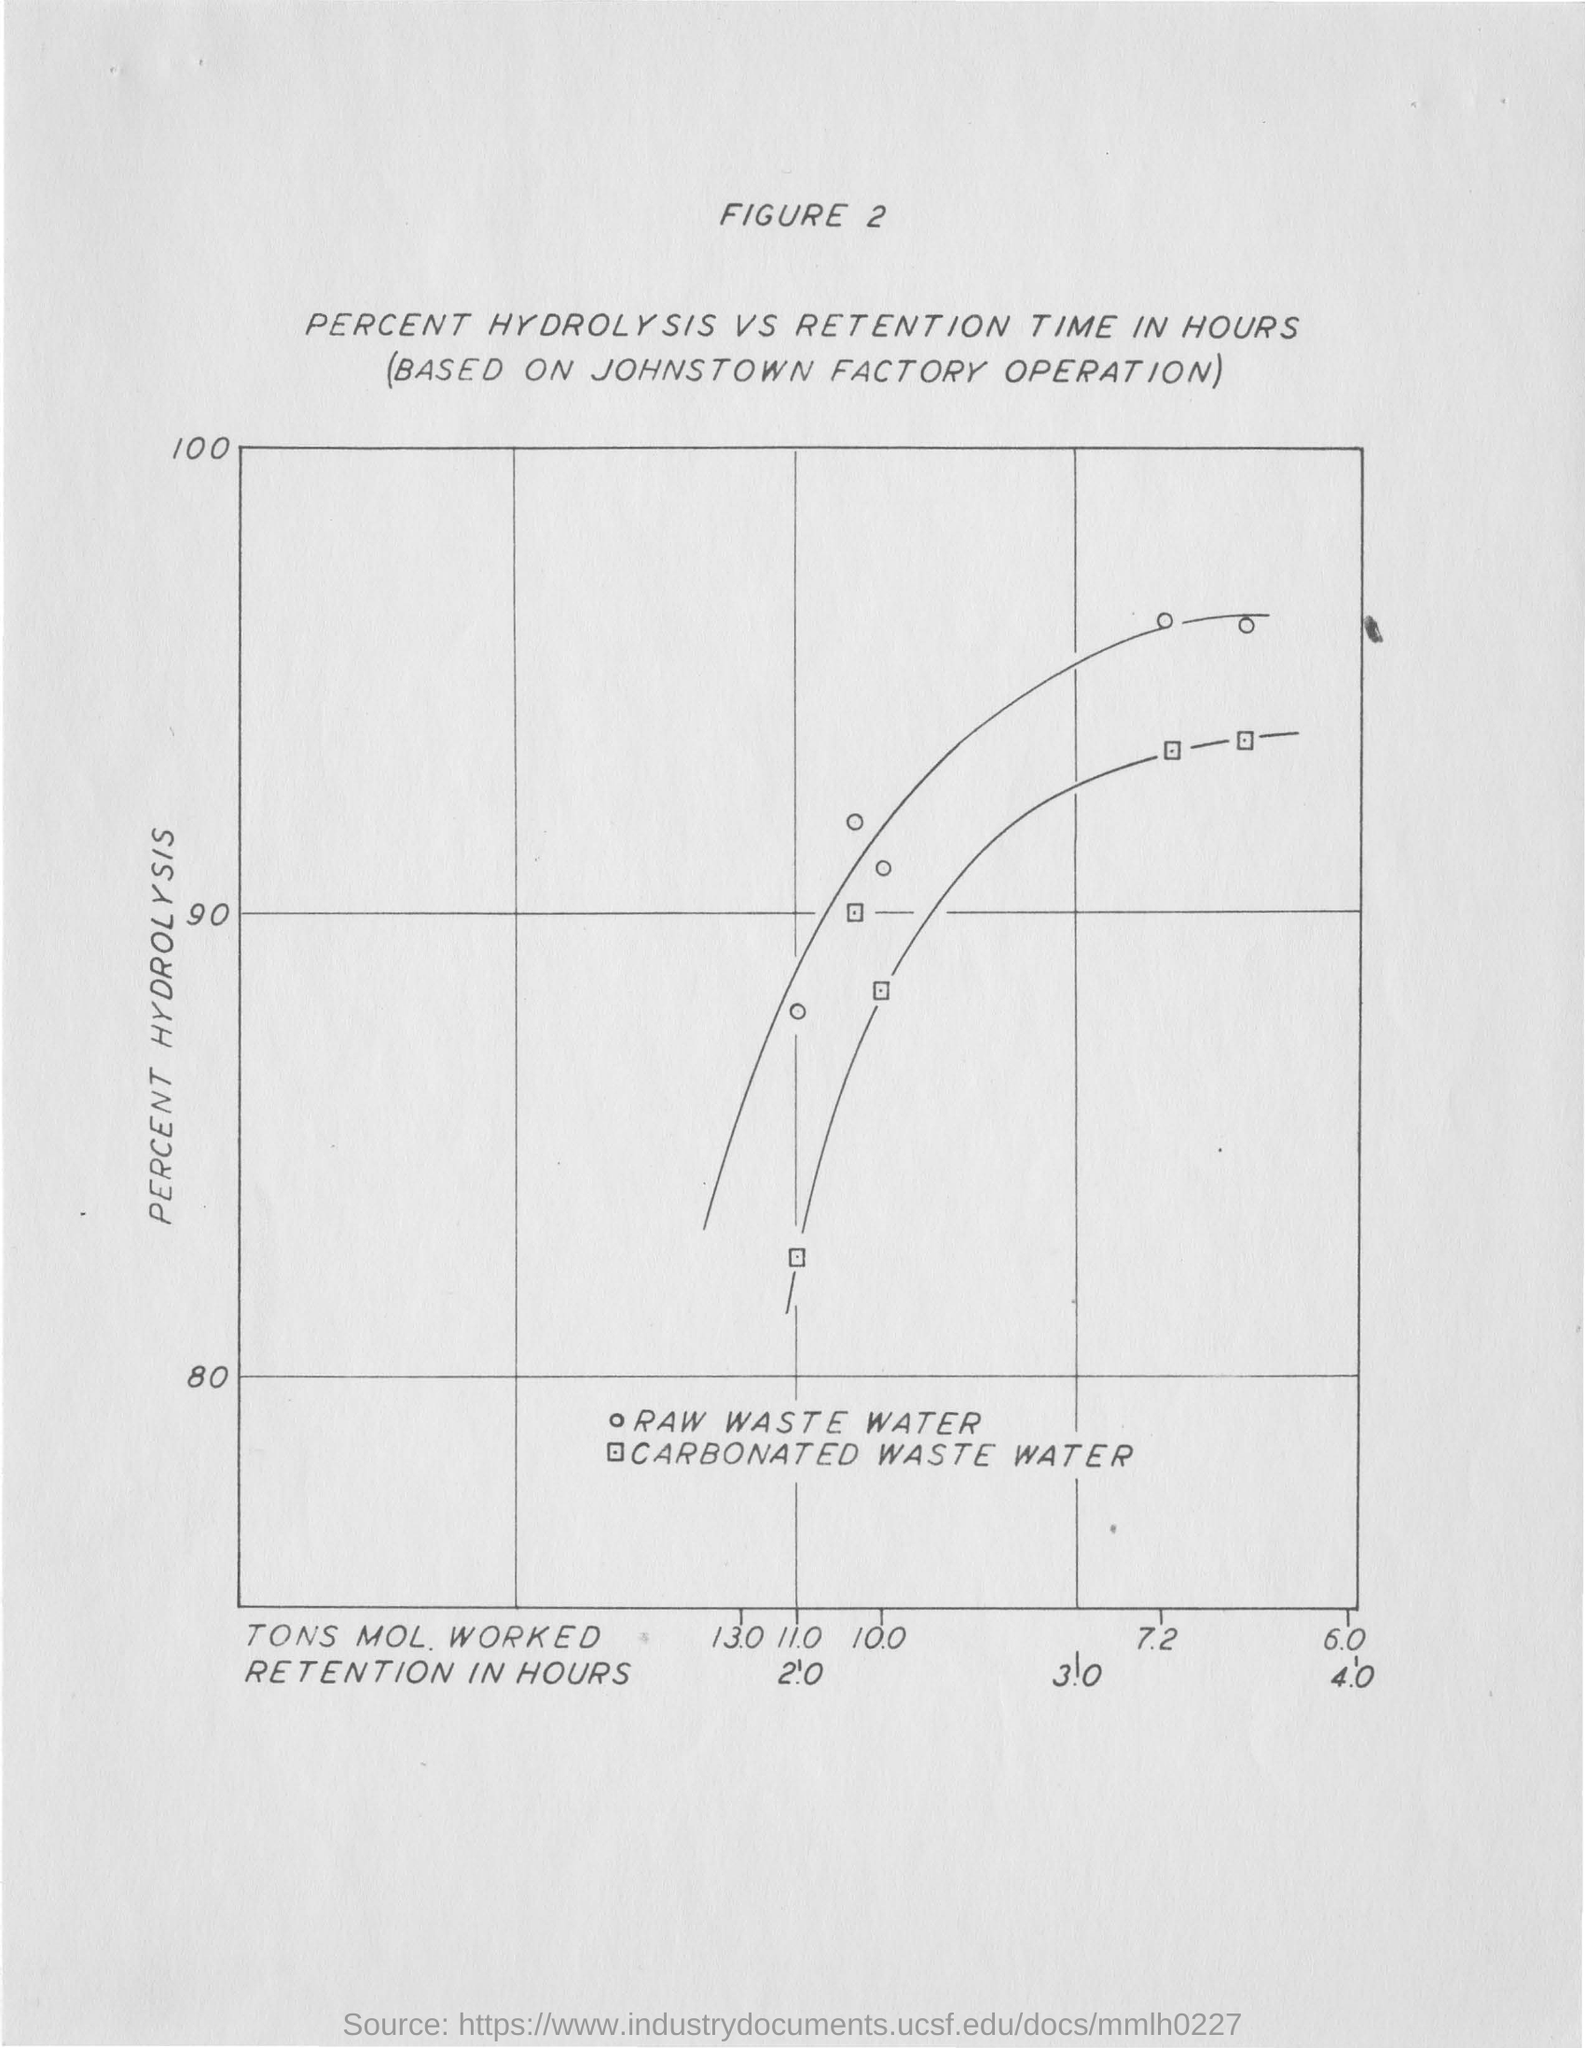Outline some significant characteristics in this image. The y-axis in the graph represents the percentage of hydrolysis that has occurred. 